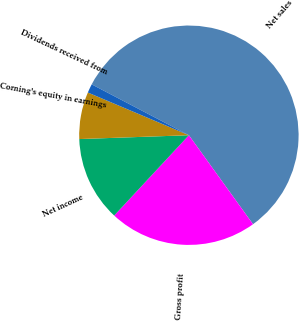Convert chart. <chart><loc_0><loc_0><loc_500><loc_500><pie_chart><fcel>Net sales<fcel>Gross profit<fcel>Net income<fcel>Corning's equity in earnings<fcel>Dividends received from<nl><fcel>57.39%<fcel>21.86%<fcel>12.52%<fcel>6.92%<fcel>1.31%<nl></chart> 